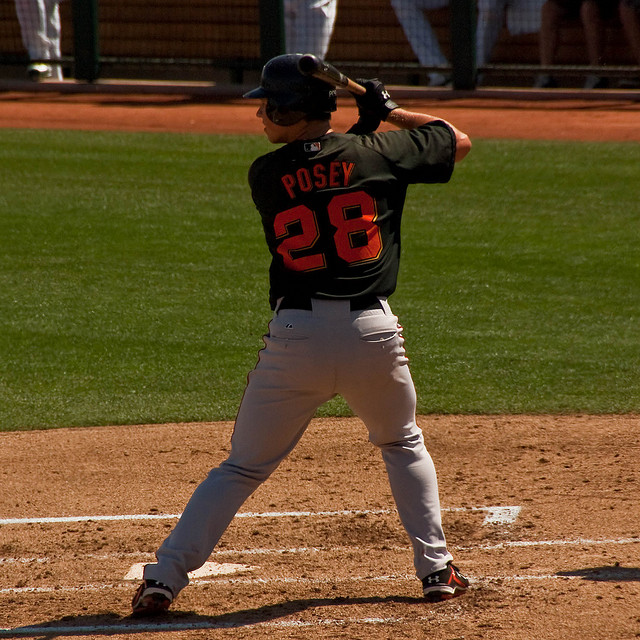Please extract the text content from this image. POSEY 28 X H X 